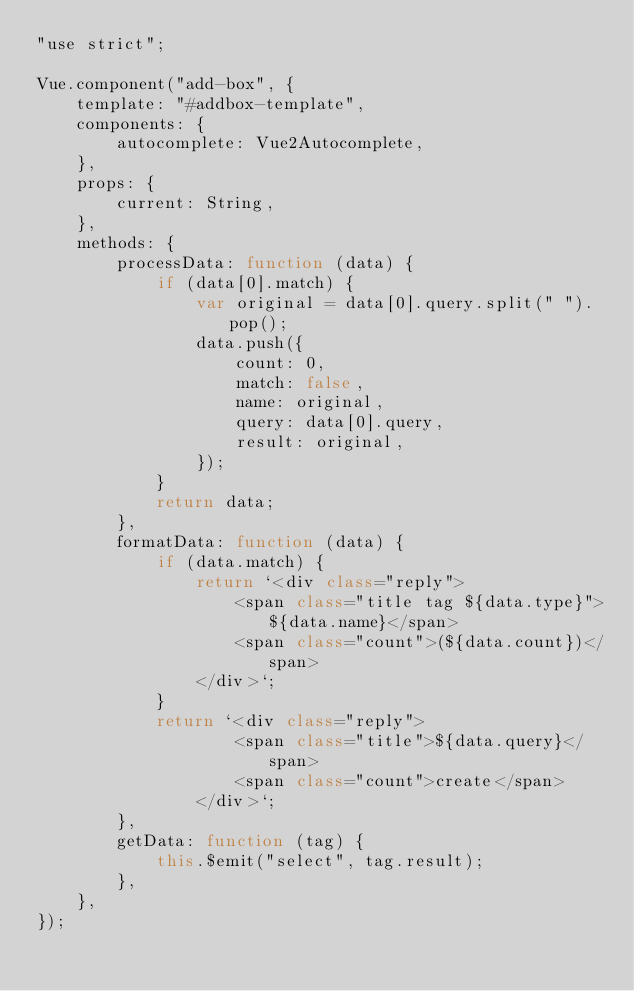<code> <loc_0><loc_0><loc_500><loc_500><_JavaScript_>"use strict";

Vue.component("add-box", {
    template: "#addbox-template",
    components: {
        autocomplete: Vue2Autocomplete,
    },
    props: {
        current: String,
    },
    methods: {
        processData: function (data) {
            if (data[0].match) {
                var original = data[0].query.split(" ").pop();
                data.push({
                    count: 0,
                    match: false,
                    name: original,
                    query: data[0].query,
                    result: original,
                });
            }
            return data;
        },
        formatData: function (data) {
            if (data.match) {
                return `<div class="reply">
                    <span class="title tag ${data.type}">${data.name}</span>
                    <span class="count">(${data.count})</span>
                </div>`;
            }
            return `<div class="reply">
                    <span class="title">${data.query}</span>
                    <span class="count">create</span>
                </div>`;
        },
        getData: function (tag) {
            this.$emit("select", tag.result);
        },
    },
});
</code> 